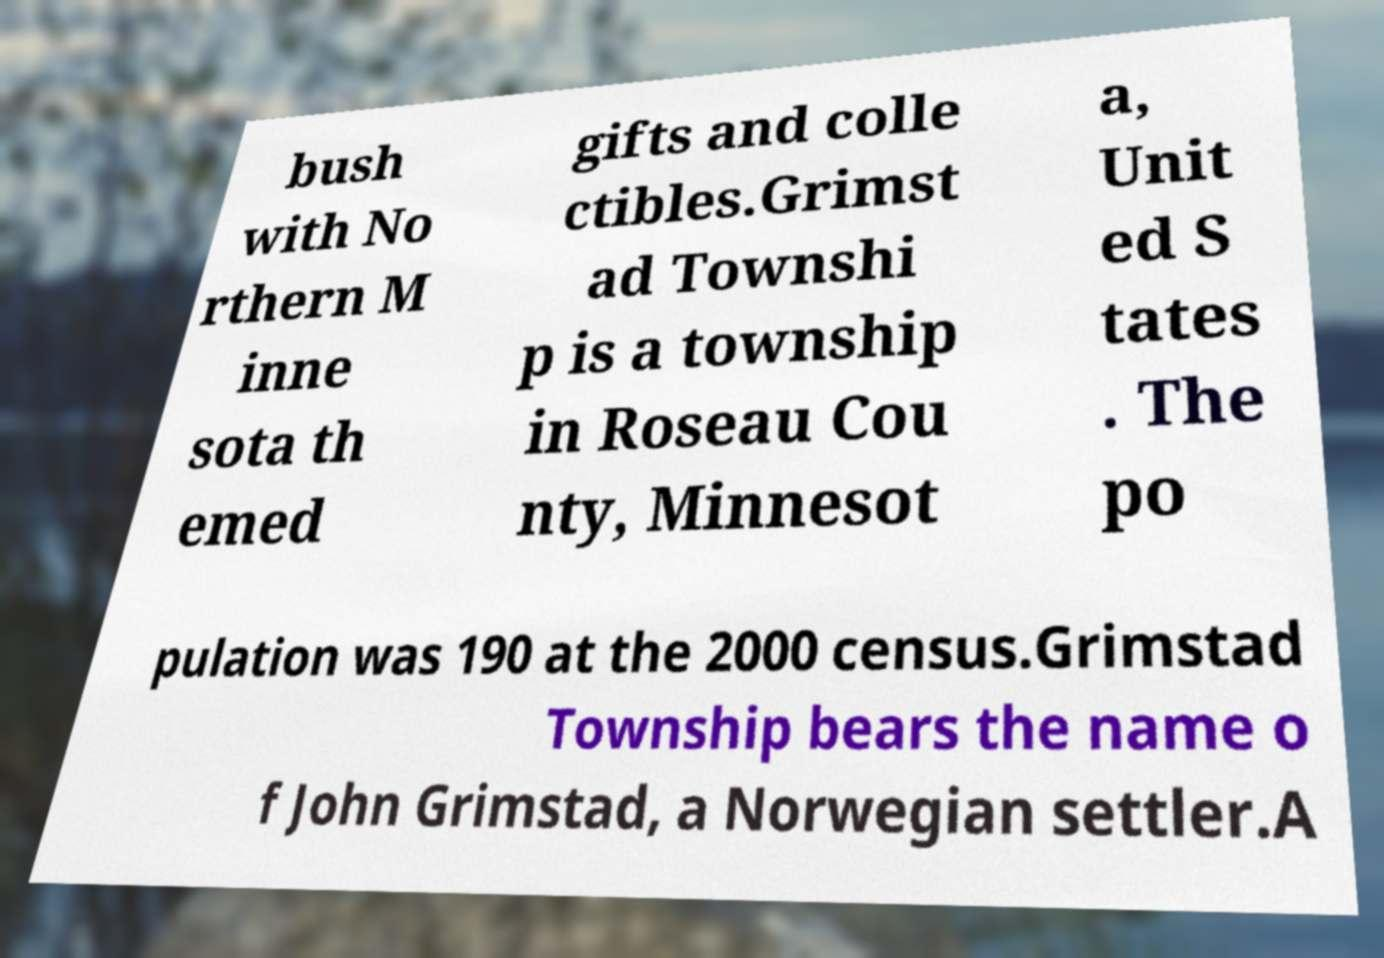Could you assist in decoding the text presented in this image and type it out clearly? bush with No rthern M inne sota th emed gifts and colle ctibles.Grimst ad Townshi p is a township in Roseau Cou nty, Minnesot a, Unit ed S tates . The po pulation was 190 at the 2000 census.Grimstad Township bears the name o f John Grimstad, a Norwegian settler.A 